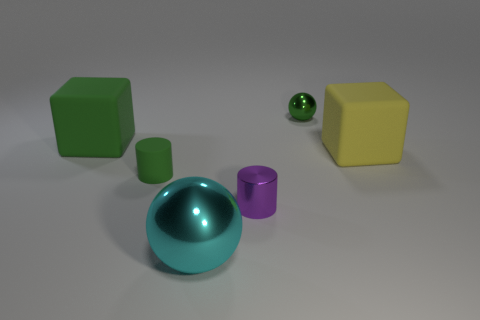The big object that is the same color as the tiny metal ball is what shape?
Offer a very short reply. Cube. Does the small green object on the left side of the green ball have the same shape as the big rubber thing that is on the left side of the big metallic thing?
Offer a very short reply. No. How many things are either yellow objects or big blocks that are behind the large yellow matte block?
Ensure brevity in your answer.  2. What is the tiny thing that is both behind the small purple object and on the right side of the small rubber cylinder made of?
Offer a very short reply. Metal. Is there anything else that has the same shape as the tiny purple metallic thing?
Your answer should be compact. Yes. What is the color of the tiny cylinder that is made of the same material as the yellow thing?
Give a very brief answer. Green. What number of objects are small balls or tiny cylinders?
Ensure brevity in your answer.  3. Is the size of the purple shiny object the same as the green matte thing that is to the right of the big green rubber object?
Keep it short and to the point. Yes. There is a small cylinder that is in front of the small matte cylinder that is on the left side of the large matte cube that is to the right of the purple shiny cylinder; what color is it?
Provide a succinct answer. Purple. What is the color of the small metal cylinder?
Keep it short and to the point. Purple. 